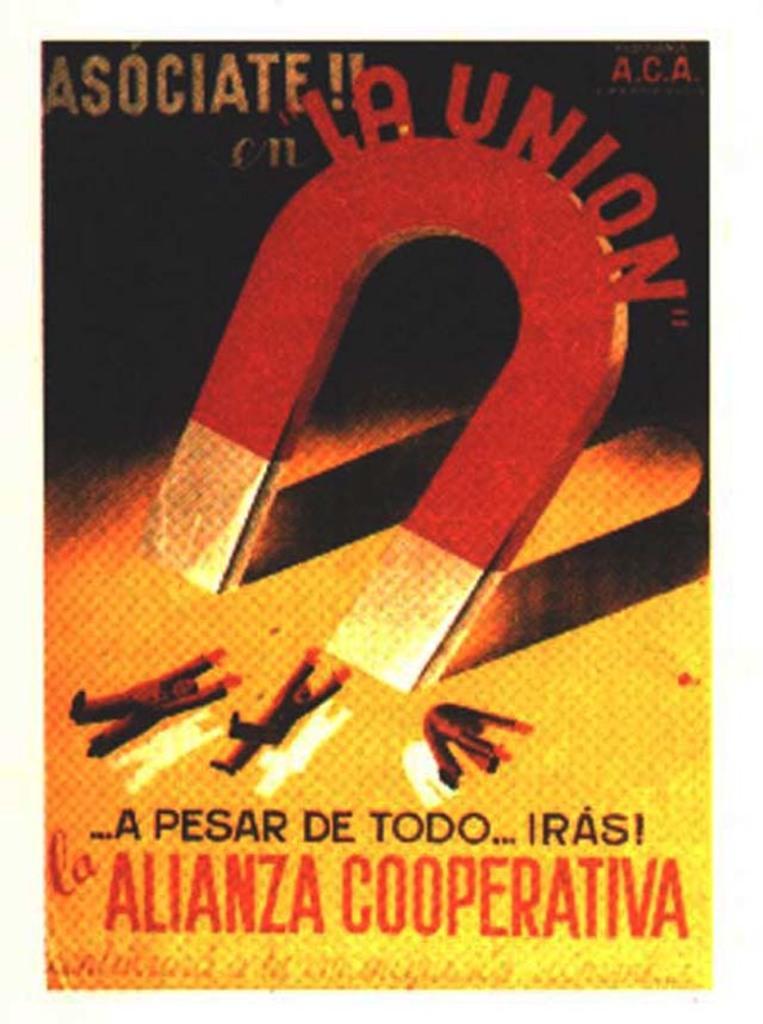Which language is this?
Your answer should be very brief. Unanswerable. Who is the author of this book?
Ensure brevity in your answer.  Alianza cooperativa. 